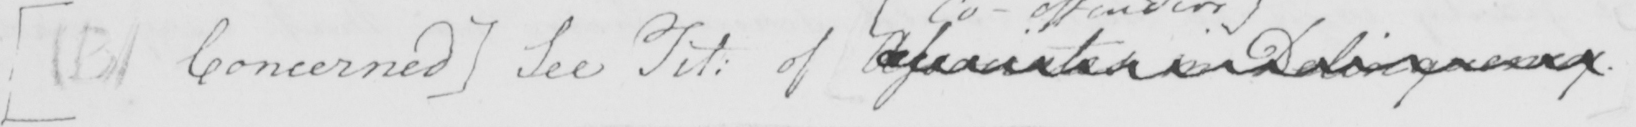What text is written in this handwritten line? [  ( B )  Concerned ]  See Tit :  of Associates in Delinquency . 